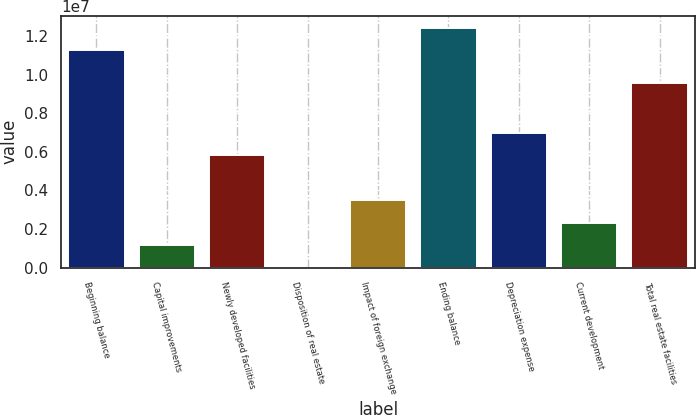<chart> <loc_0><loc_0><loc_500><loc_500><bar_chart><fcel>Beginning balance<fcel>Capital improvements<fcel>Newly developed facilities<fcel>Disposition of real estate<fcel>Impact of foreign exchange<fcel>Ending balance<fcel>Depreciation expense<fcel>Current development<fcel>Total real estate facilities<nl><fcel>1.12619e+07<fcel>1.16966e+06<fcel>5.8315e+06<fcel>4202<fcel>3.50058e+06<fcel>1.24273e+07<fcel>6.99696e+06<fcel>2.33512e+06<fcel>9.58255e+06<nl></chart> 